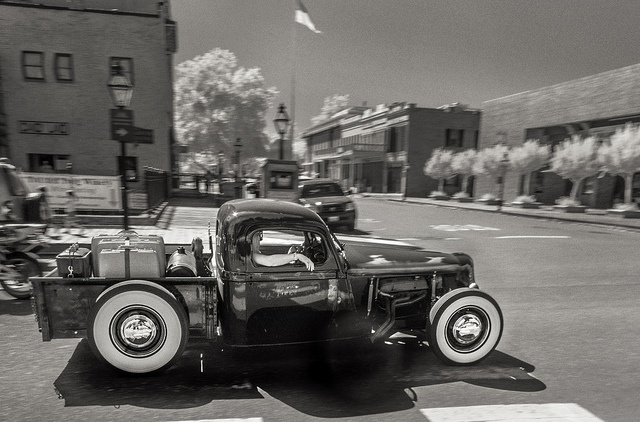Describe the objects in this image and their specific colors. I can see truck in black, gray, darkgray, and lightgray tones, suitcase in black, darkgray, gray, and lightgray tones, motorcycle in black, gray, darkgray, and lightgray tones, car in black, gray, and darkgray tones, and suitcase in black, gray, darkgray, and lightgray tones in this image. 